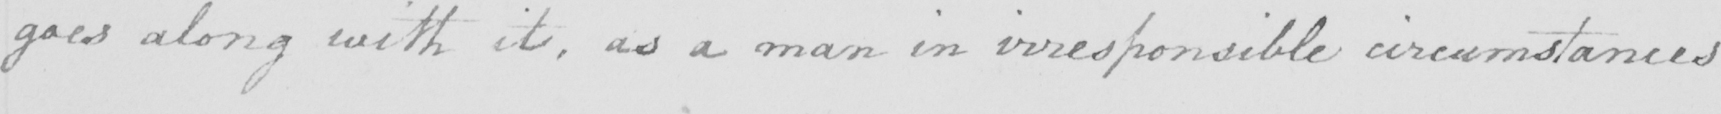What text is written in this handwritten line? goes along with it , as a man in irresponsible circumstances 